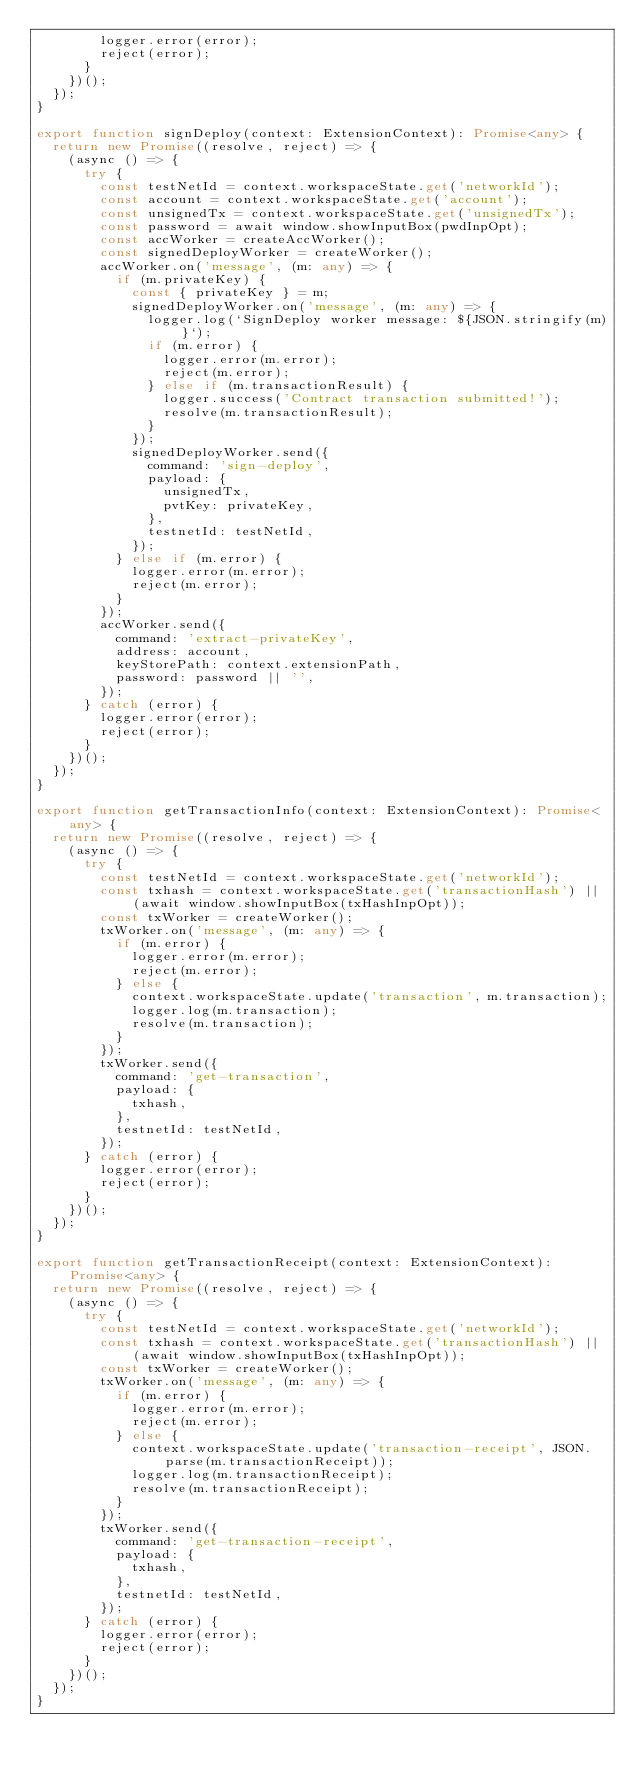<code> <loc_0><loc_0><loc_500><loc_500><_TypeScript_>        logger.error(error);
        reject(error);
      }
    })();
  });
}

export function signDeploy(context: ExtensionContext): Promise<any> {
  return new Promise((resolve, reject) => {
    (async () => {
      try {
        const testNetId = context.workspaceState.get('networkId');
        const account = context.workspaceState.get('account');
        const unsignedTx = context.workspaceState.get('unsignedTx');
        const password = await window.showInputBox(pwdInpOpt);
        const accWorker = createAccWorker();
        const signedDeployWorker = createWorker();
        accWorker.on('message', (m: any) => {
          if (m.privateKey) {
            const { privateKey } = m;
            signedDeployWorker.on('message', (m: any) => {
              logger.log(`SignDeploy worker message: ${JSON.stringify(m)}`);
              if (m.error) {
                logger.error(m.error);
                reject(m.error);
              } else if (m.transactionResult) {
                logger.success('Contract transaction submitted!');
                resolve(m.transactionResult);
              }
            });
            signedDeployWorker.send({
              command: 'sign-deploy',
              payload: {
                unsignedTx,
                pvtKey: privateKey,
              },
              testnetId: testNetId,
            });
          } else if (m.error) {
            logger.error(m.error);
            reject(m.error);
          }
        });
        accWorker.send({
          command: 'extract-privateKey',
          address: account,
          keyStorePath: context.extensionPath,
          password: password || '',
        });
      } catch (error) {
        logger.error(error);
        reject(error);
      }
    })();
  });
}

export function getTransactionInfo(context: ExtensionContext): Promise<any> {
  return new Promise((resolve, reject) => {
    (async () => {
      try {
        const testNetId = context.workspaceState.get('networkId');
        const txhash = context.workspaceState.get('transactionHash') || (await window.showInputBox(txHashInpOpt));
        const txWorker = createWorker();
        txWorker.on('message', (m: any) => {
          if (m.error) {
            logger.error(m.error);
            reject(m.error);
          } else {
            context.workspaceState.update('transaction', m.transaction);
            logger.log(m.transaction);
            resolve(m.transaction);
          }
        });
        txWorker.send({
          command: 'get-transaction',
          payload: {
            txhash,
          },
          testnetId: testNetId,
        });
      } catch (error) {
        logger.error(error);
        reject(error);
      }
    })();
  });
}

export function getTransactionReceipt(context: ExtensionContext): Promise<any> {
  return new Promise((resolve, reject) => {
    (async () => {
      try {
        const testNetId = context.workspaceState.get('networkId');
        const txhash = context.workspaceState.get('transactionHash') || (await window.showInputBox(txHashInpOpt));
        const txWorker = createWorker();
        txWorker.on('message', (m: any) => {
          if (m.error) {
            logger.error(m.error);
            reject(m.error);
          } else {
            context.workspaceState.update('transaction-receipt', JSON.parse(m.transactionReceipt));
            logger.log(m.transactionReceipt);
            resolve(m.transactionReceipt);
          }
        });
        txWorker.send({
          command: 'get-transaction-receipt',
          payload: {
            txhash,
          },
          testnetId: testNetId,
        });
      } catch (error) {
        logger.error(error);
        reject(error);
      }
    })();
  });
}
</code> 